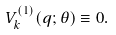Convert formula to latex. <formula><loc_0><loc_0><loc_500><loc_500>V _ { k } ^ { ( 1 ) } ( q ; \theta ) \equiv 0 .</formula> 